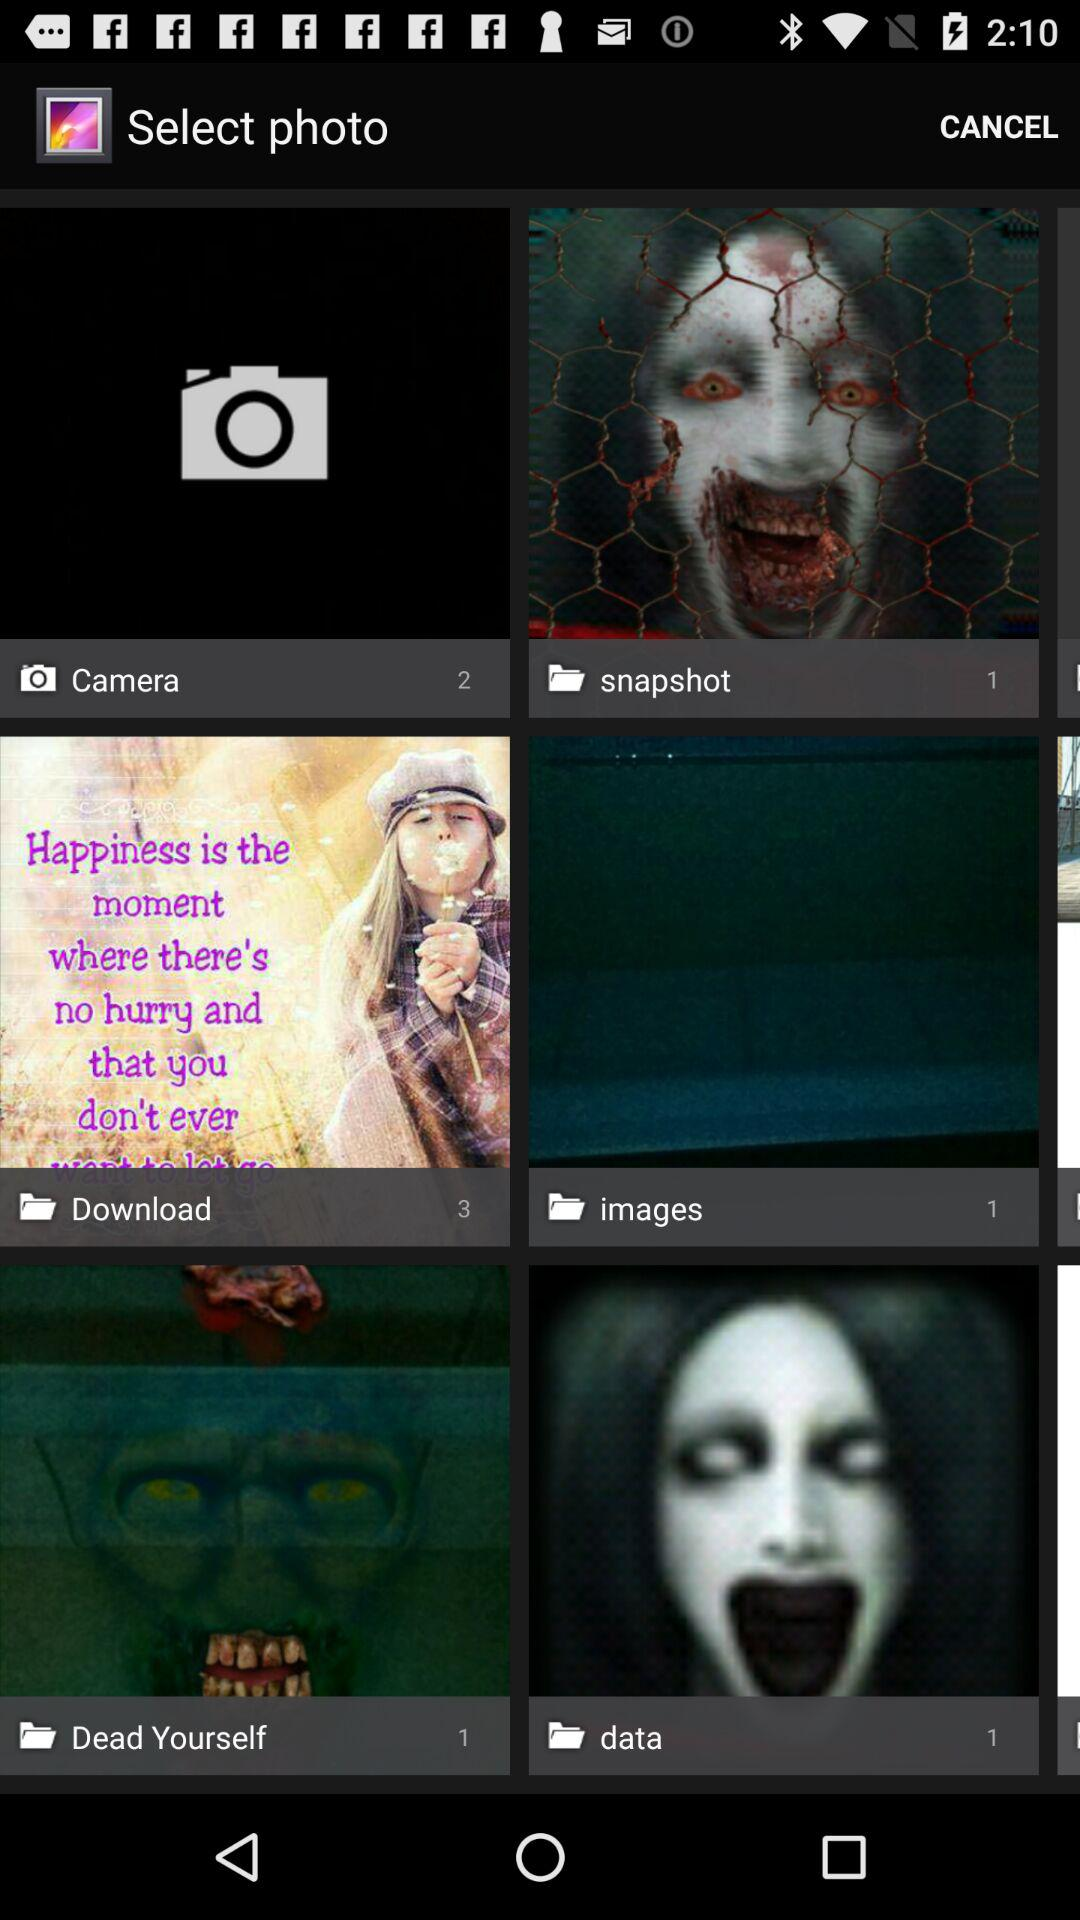What are the names of the folders present in "Select photo"? The names of the folders are Camera, snapshot, Download, images, Dead Yourself and data. 